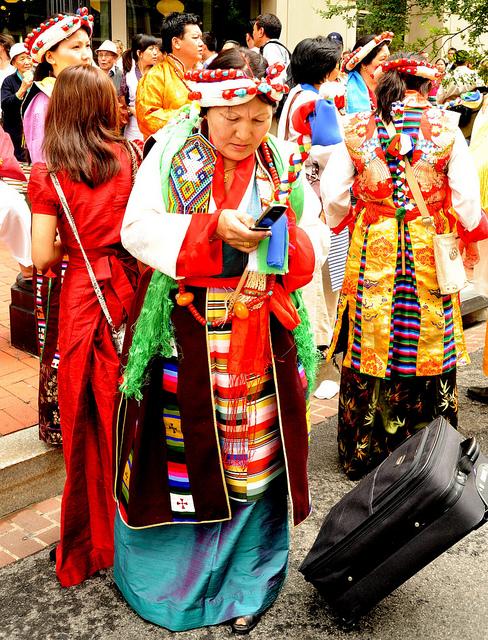What color is the woman's skirt?
Concise answer only. Blue. Are these costumes heavy?
Keep it brief. Yes. Of which country are these costumes representative?
Write a very short answer. India. Are these people on vacation?
Keep it brief. Yes. What country is typically associated with this holiday?
Answer briefly. China. 